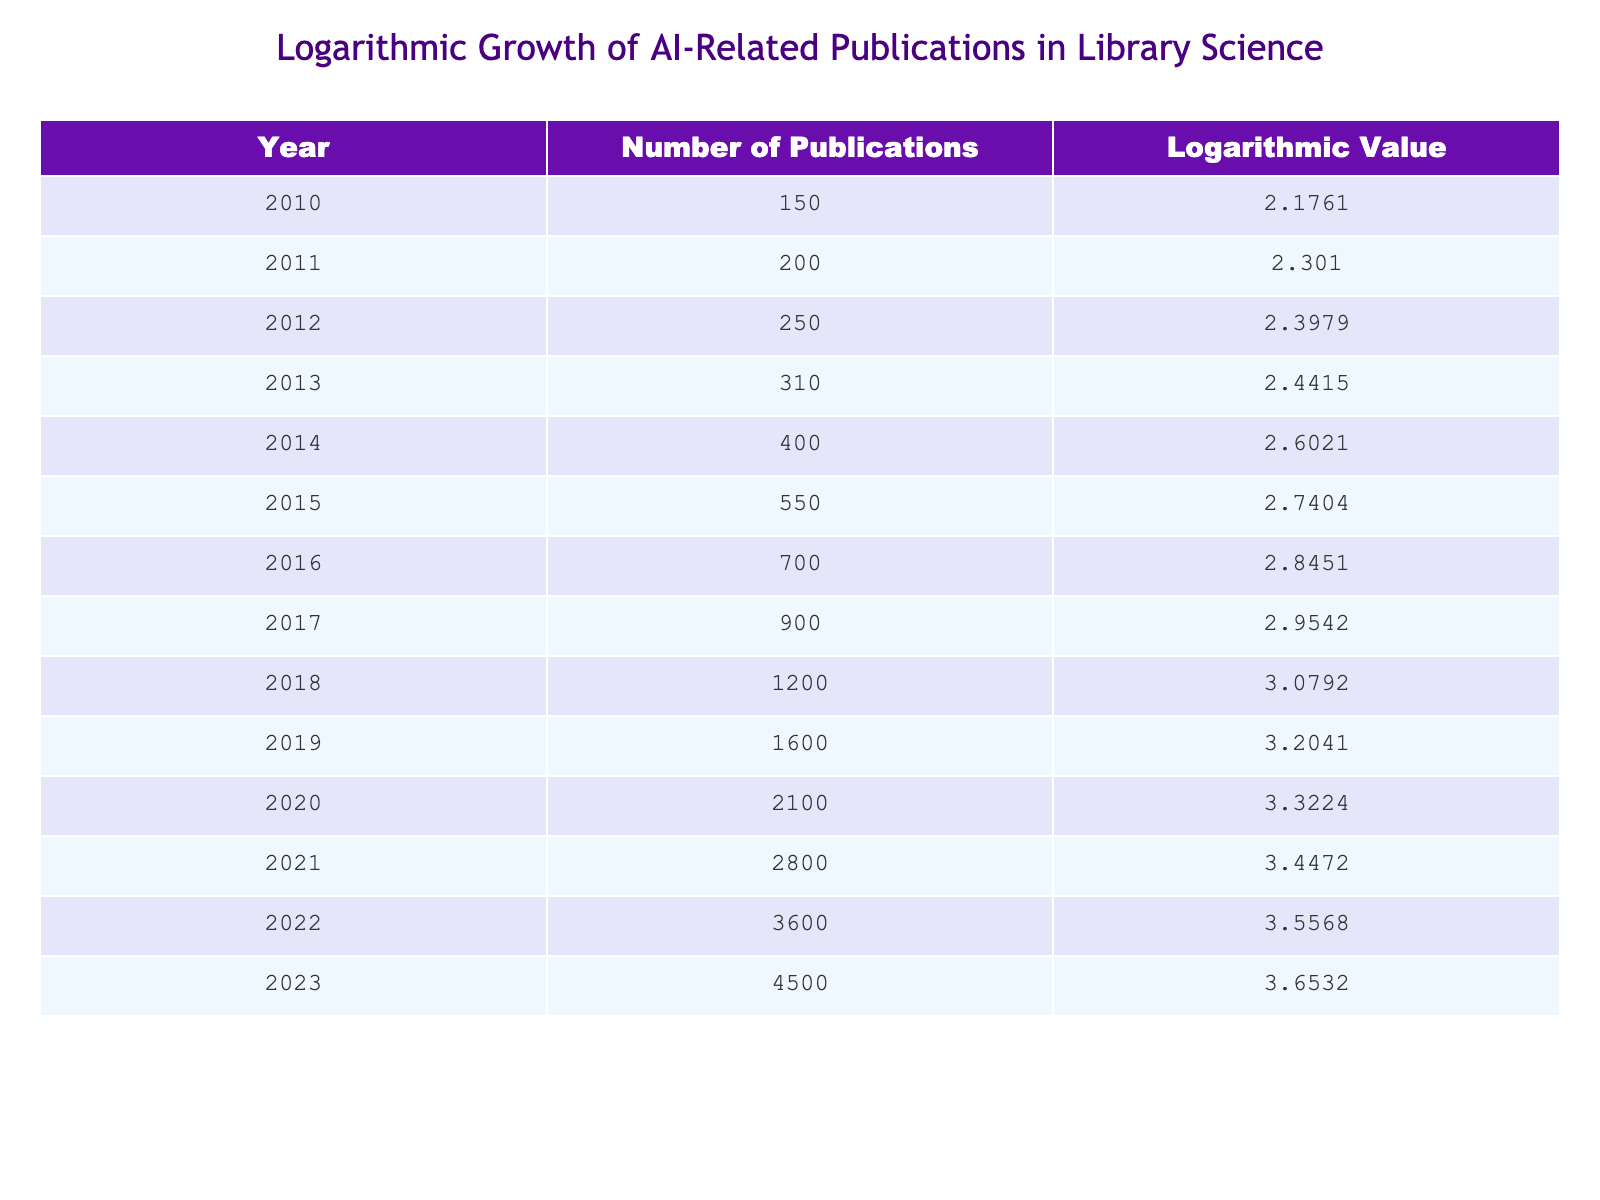What was the number of AI-related publications in library science in 2020? According to the table, the number of AI-related publications in 2020 was listed directly next to the corresponding year. In 2020, it shows 2100.
Answer: 2100 What is the logarithmic value corresponding to the number of publications in 2018? The logarithmic value can be found in the table by locating the year 2018 and checking the associated logarithmic value, which is 3.0792.
Answer: 3.0792 How many more publications were there in 2023 compared to 2011? To find the difference, first identify the number of publications for both years: in 2023 there were 4500 and in 2011 there were 200. The difference is calculated as 4500 - 200 = 4300.
Answer: 4300 What is the average number of publications from 2015 to 2023? First, sum the number of publications for the years from 2015 to 2023: 550, 700, 900, 1200, 1600, 2100, 2800, 3600, 4500. The sum is 550 + 700 + 900 + 1200 + 1600 + 2100 + 2800 + 3600 + 4500 = 20550. There are 9 years, so the average is 20550 / 9 = 2283.33.
Answer: 2283.33 Did the number of publications in 2022 exceed the number in 2017? To answer this, compare the numbers for the two years. In 2022, the publications were 3600 and in 2017 they were 900. Since 3600 is greater than 900, the answer is yes.
Answer: Yes What was the increase in the logarithmic value from 2015 to 2020? First, identify the logarithmic values for these years: in 2015, the value is 2.7404, and in 2020, it is 3.3224. The increase is calculated as 3.3224 - 2.7404 = 0.5820.
Answer: 0.5820 Were there more than 3000 publications in 2021? Looking at the table, the number of publications in 2021 is listed as 2800, which is less than 3000. Therefore, the answer is no.
Answer: No What percentage increase in publications occurred from 2016 to 2023? For the percentage increase, use the formula: ((new value - old value)/old value) * 100. The publications in 2016 were 700 and in 2023 were 4500. The calculation is ((4500 - 700) / 700) * 100 = (4300 / 700) * 100 = 614.29%.
Answer: 614.29% 